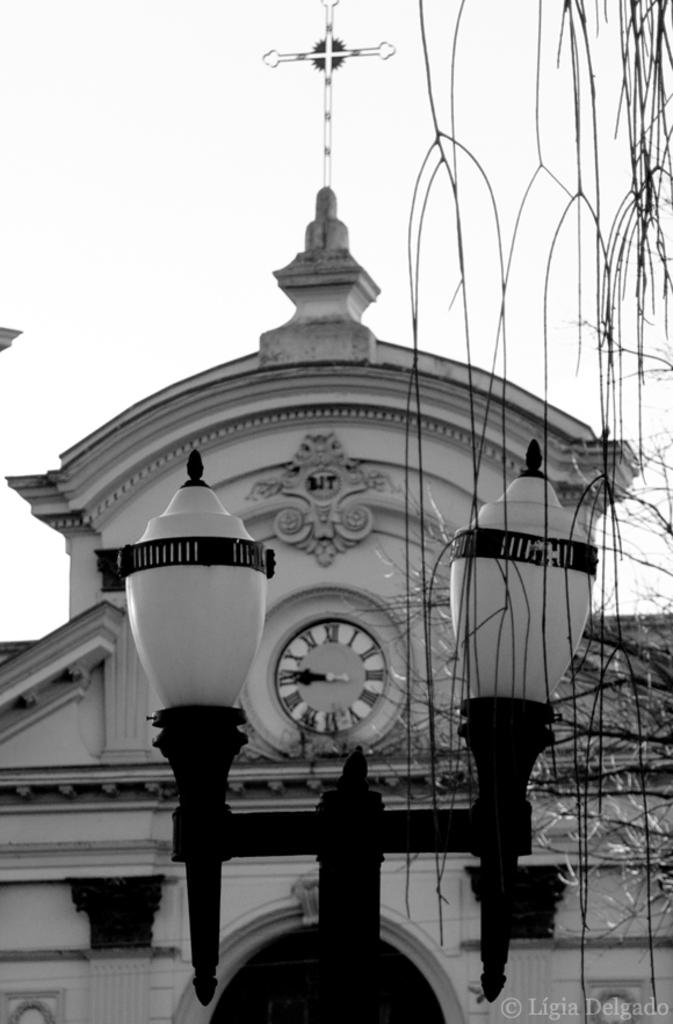What is on the pole that is visible in the image? There are lights on the pole in the image. What structure is located behind the pole? There is a building behind the pole. What symbol can be seen on the building? The building has a holly cross symbol. What is visible behind the building in the image? The sky is visible behind the building. Where is the bike located in the image? There is no bike present in the image. Can you see a swing in the image? There is no swing present in the image. 